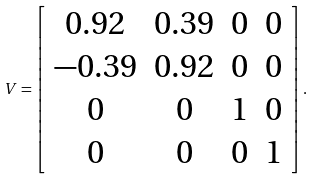Convert formula to latex. <formula><loc_0><loc_0><loc_500><loc_500>V = \left [ \begin{array} { c c c c } 0 . 9 2 & 0 . 3 9 & 0 & 0 \\ - 0 . 3 9 & 0 . 9 2 & 0 & 0 \\ 0 & 0 & 1 & 0 \\ 0 & 0 & 0 & 1 \end{array} \right ] .</formula> 